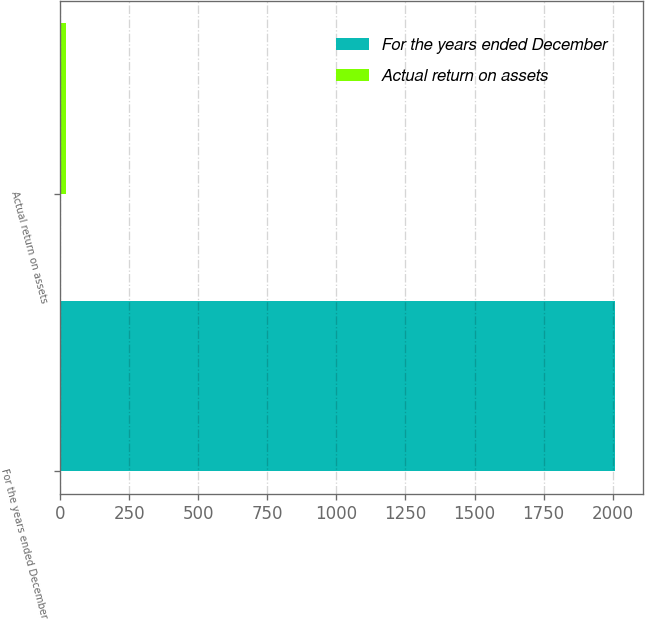Convert chart to OTSL. <chart><loc_0><loc_0><loc_500><loc_500><bar_chart><fcel>For the years ended December<fcel>Actual return on assets<nl><fcel>2009<fcel>21.2<nl></chart> 